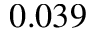<formula> <loc_0><loc_0><loc_500><loc_500>0 . 0 3 9</formula> 